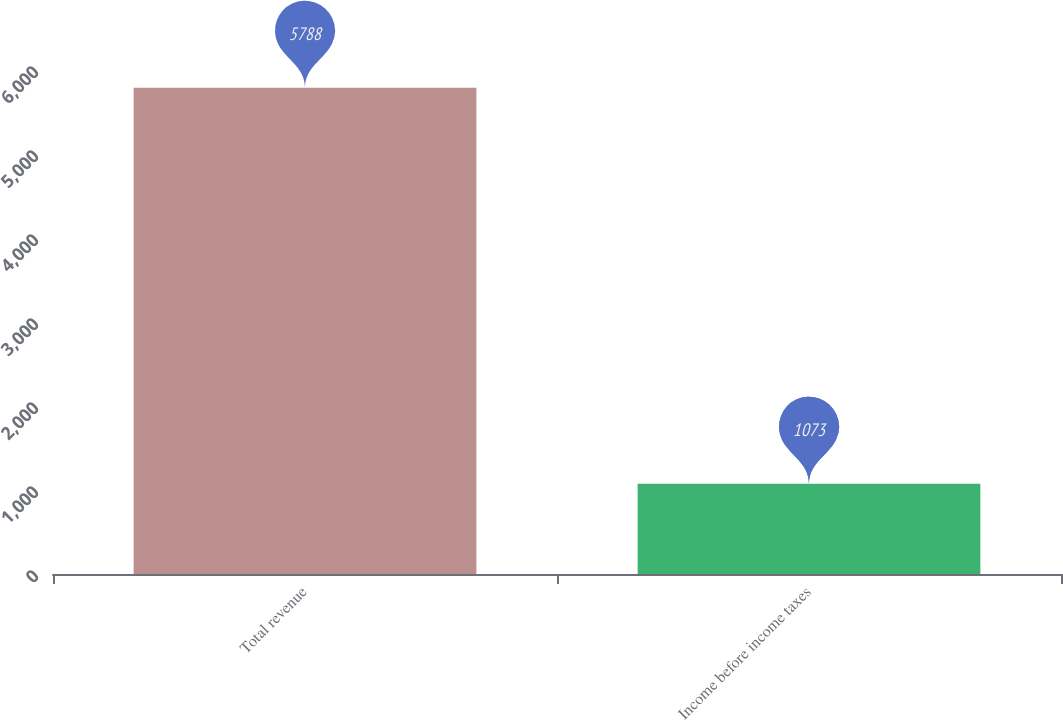Convert chart to OTSL. <chart><loc_0><loc_0><loc_500><loc_500><bar_chart><fcel>Total revenue<fcel>Income before income taxes<nl><fcel>5788<fcel>1073<nl></chart> 